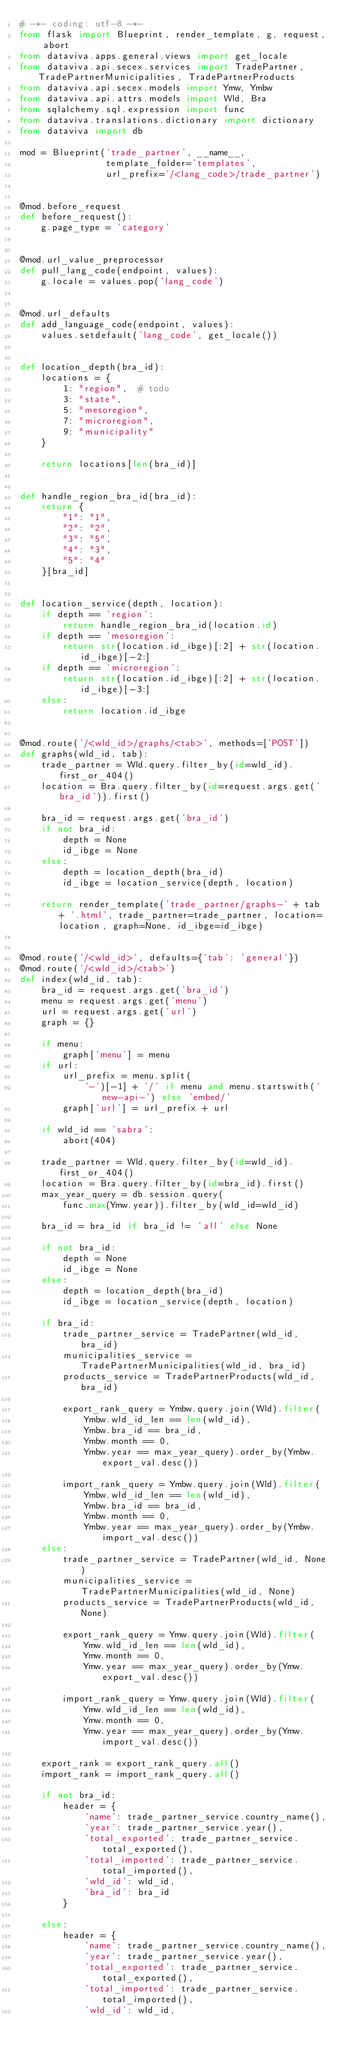<code> <loc_0><loc_0><loc_500><loc_500><_Python_># -*- coding: utf-8 -*-
from flask import Blueprint, render_template, g, request, abort
from dataviva.apps.general.views import get_locale
from dataviva.api.secex.services import TradePartner, TradePartnerMunicipalities, TradePartnerProducts
from dataviva.api.secex.models import Ymw, Ymbw
from dataviva.api.attrs.models import Wld, Bra
from sqlalchemy.sql.expression import func
from dataviva.translations.dictionary import dictionary
from dataviva import db

mod = Blueprint('trade_partner', __name__,
                template_folder='templates',
                url_prefix='/<lang_code>/trade_partner')


@mod.before_request
def before_request():
    g.page_type = 'category'


@mod.url_value_preprocessor
def pull_lang_code(endpoint, values):
    g.locale = values.pop('lang_code')


@mod.url_defaults
def add_language_code(endpoint, values):
    values.setdefault('lang_code', get_locale())


def location_depth(bra_id):
    locations = {
        1: "region",  # todo
        3: "state",
        5: "mesoregion",
        7: "microregion",
        9: "municipality"
    }

    return locations[len(bra_id)]


def handle_region_bra_id(bra_id):
    return {
        "1": "1",
        "2": "2",
        "3": "5",
        "4": "3",
        "5": "4"
    }[bra_id]


def location_service(depth, location):
    if depth == 'region':
        return handle_region_bra_id(location.id)
    if depth == 'mesoregion':
        return str(location.id_ibge)[:2] + str(location.id_ibge)[-2:]
    if depth == 'microregion':
        return str(location.id_ibge)[:2] + str(location.id_ibge)[-3:]
    else:
        return location.id_ibge


@mod.route('/<wld_id>/graphs/<tab>', methods=['POST'])
def graphs(wld_id, tab):
    trade_partner = Wld.query.filter_by(id=wld_id).first_or_404()
    location = Bra.query.filter_by(id=request.args.get('bra_id')).first()

    bra_id = request.args.get('bra_id')
    if not bra_id:
        depth = None
        id_ibge = None
    else:
        depth = location_depth(bra_id)
        id_ibge = location_service(depth, location)

    return render_template('trade_partner/graphs-' + tab + '.html', trade_partner=trade_partner, location=location, graph=None, id_ibge=id_ibge)


@mod.route('/<wld_id>', defaults={'tab': 'general'})
@mod.route('/<wld_id>/<tab>')
def index(wld_id, tab):
    bra_id = request.args.get('bra_id')
    menu = request.args.get('menu')
    url = request.args.get('url')
    graph = {}

    if menu:
        graph['menu'] = menu
    if url:
        url_prefix = menu.split(
            '-')[-1] + '/' if menu and menu.startswith('new-api-') else 'embed/'
        graph['url'] = url_prefix + url

    if wld_id == 'sabra':
        abort(404)

    trade_partner = Wld.query.filter_by(id=wld_id).first_or_404()
    location = Bra.query.filter_by(id=bra_id).first()
    max_year_query = db.session.query(
        func.max(Ymw.year)).filter_by(wld_id=wld_id)

    bra_id = bra_id if bra_id != 'all' else None

    if not bra_id:
        depth = None
        id_ibge = None
    else:
        depth = location_depth(bra_id)
        id_ibge = location_service(depth, location)

    if bra_id:
        trade_partner_service = TradePartner(wld_id, bra_id)
        municipalities_service = TradePartnerMunicipalities(wld_id, bra_id)
        products_service = TradePartnerProducts(wld_id, bra_id)

        export_rank_query = Ymbw.query.join(Wld).filter(
            Ymbw.wld_id_len == len(wld_id),
            Ymbw.bra_id == bra_id,
            Ymbw.month == 0,
            Ymbw.year == max_year_query).order_by(Ymbw.export_val.desc())

        import_rank_query = Ymbw.query.join(Wld).filter(
            Ymbw.wld_id_len == len(wld_id),
            Ymbw.bra_id == bra_id,
            Ymbw.month == 0,
            Ymbw.year == max_year_query).order_by(Ymbw.import_val.desc())
    else:
        trade_partner_service = TradePartner(wld_id, None)
        municipalities_service = TradePartnerMunicipalities(wld_id, None)
        products_service = TradePartnerProducts(wld_id, None)

        export_rank_query = Ymw.query.join(Wld).filter(
            Ymw.wld_id_len == len(wld_id),
            Ymw.month == 0,
            Ymw.year == max_year_query).order_by(Ymw.export_val.desc())

        import_rank_query = Ymw.query.join(Wld).filter(
            Ymw.wld_id_len == len(wld_id),
            Ymw.month == 0,
            Ymw.year == max_year_query).order_by(Ymw.import_val.desc())

    export_rank = export_rank_query.all()
    import_rank = import_rank_query.all()

    if not bra_id:
        header = {
            'name': trade_partner_service.country_name(),
            'year': trade_partner_service.year(),
            'total_exported': trade_partner_service.total_exported(),
            'total_imported': trade_partner_service.total_imported(),
            'wld_id': wld_id,
            'bra_id': bra_id
        }

    else:
        header = {
            'name': trade_partner_service.country_name(),
            'year': trade_partner_service.year(),
            'total_exported': trade_partner_service.total_exported(),
            'total_imported': trade_partner_service.total_imported(),
            'wld_id': wld_id,</code> 